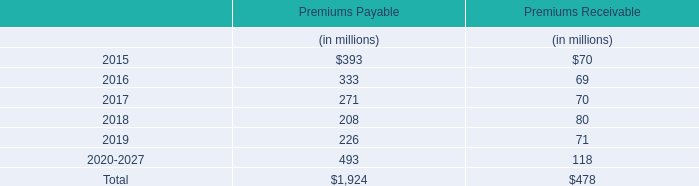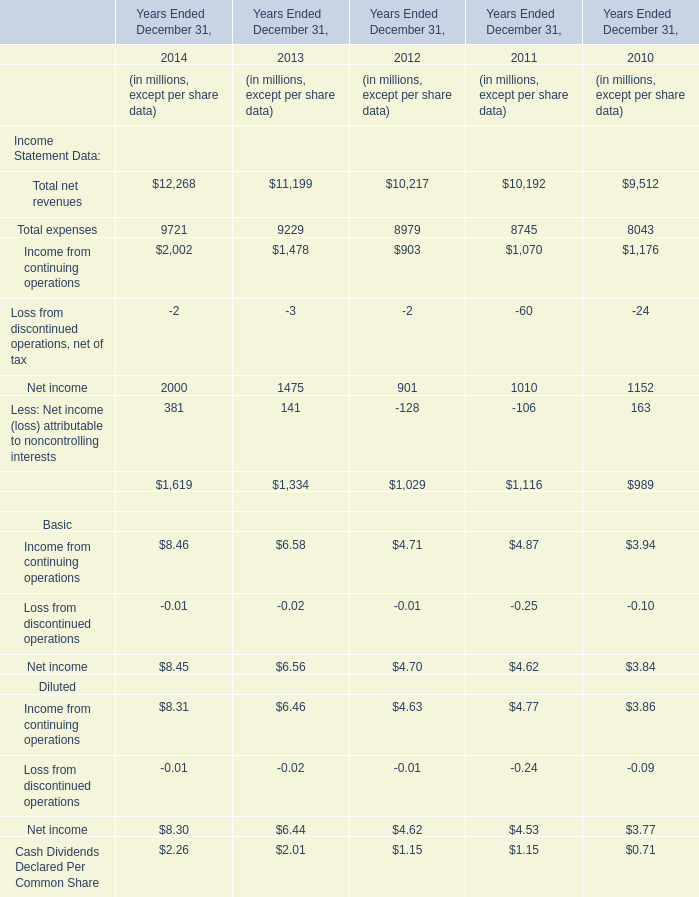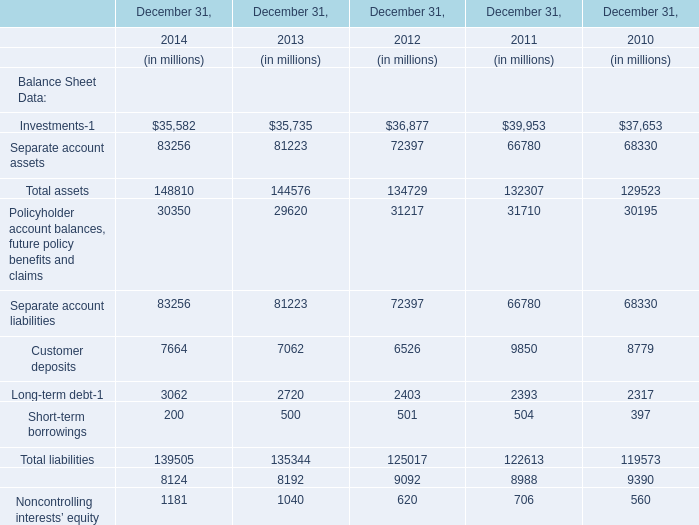In the year with largest amount of Income Statement Data: Total net revenues, what's the increasing rate of Income Statement Data: Total expenses? 
Computations: ((9721 - 9229) / 9229)
Answer: 0.05331. 